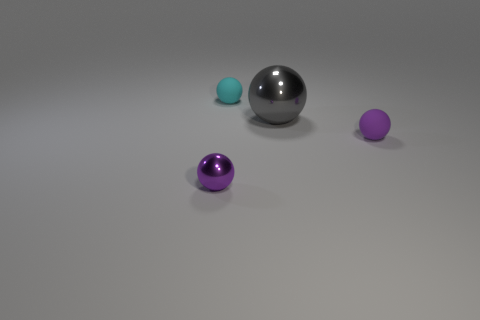What number of other shiny objects have the same shape as the small cyan thing?
Your answer should be very brief. 2. There is a cyan thing on the left side of the rubber ball in front of the gray shiny sphere; what is its material?
Make the answer very short. Rubber. The other tiny object that is the same color as the small metal thing is what shape?
Provide a short and direct response. Sphere. Is there a tiny gray object made of the same material as the small cyan sphere?
Keep it short and to the point. No. What is the shape of the cyan object?
Your answer should be very brief. Sphere. How many brown balls are there?
Provide a short and direct response. 0. What color is the tiny ball that is to the left of the small rubber object on the left side of the small purple rubber object?
Keep it short and to the point. Purple. There is a rubber ball that is the same size as the cyan matte object; what color is it?
Offer a very short reply. Purple. Is there a small block that has the same color as the big thing?
Your answer should be very brief. No. Are there any large yellow shiny cylinders?
Make the answer very short. No. 